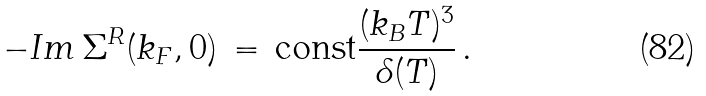<formula> <loc_0><loc_0><loc_500><loc_500>- I m \, \Sigma ^ { R } ( k _ { F } , 0 ) \, = \, \text {const} \frac { ( k _ { B } T ) ^ { 3 } } { \delta ( T ) } \, .</formula> 